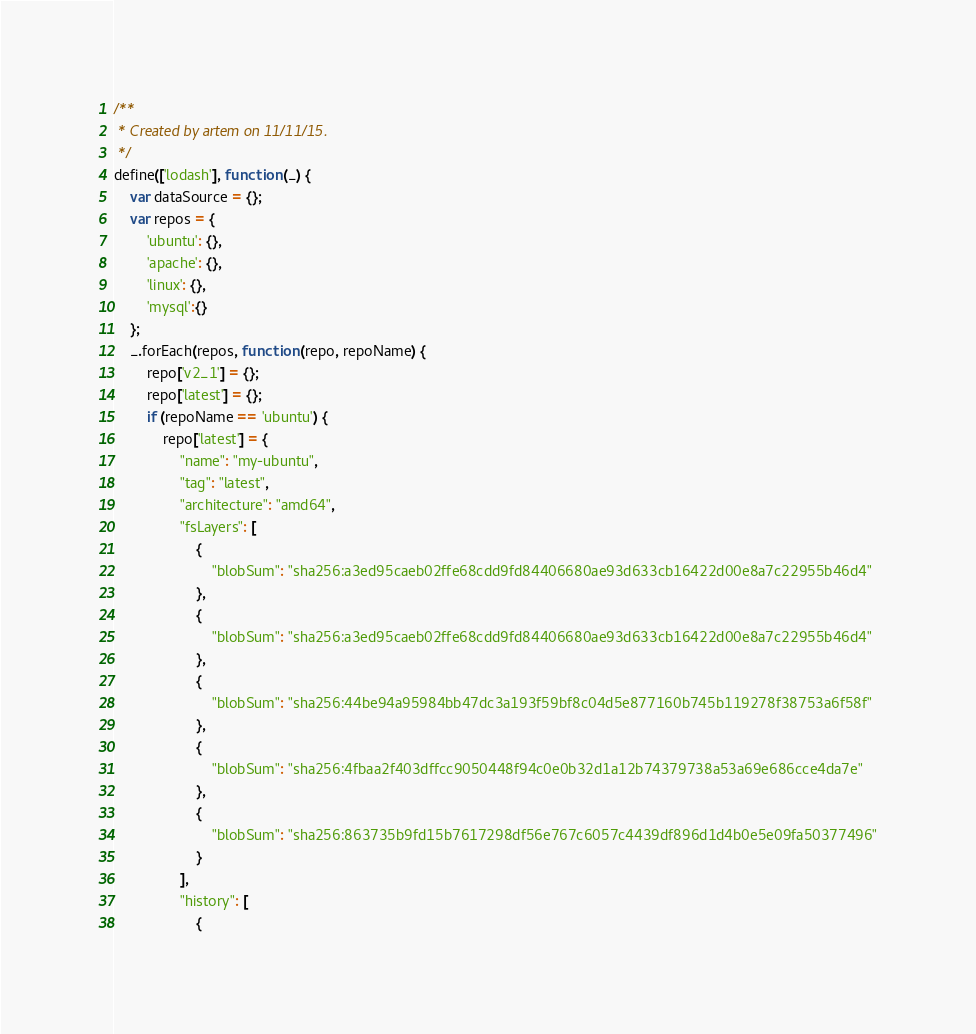Convert code to text. <code><loc_0><loc_0><loc_500><loc_500><_JavaScript_>/**
 * Created by artem on 11/11/15.
 */
define(['lodash'], function (_) {
    var dataSource = {};
    var repos = {
        'ubuntu': {},
        'apache': {},
        'linux': {},
        'mysql':{}
    };
    _.forEach(repos, function (repo, repoName) {
        repo['v2_1'] = {};
        repo['latest'] = {};
        if (repoName == 'ubuntu') {
            repo['latest'] = {
                "name": "my-ubuntu",
                "tag": "latest",
                "architecture": "amd64",
                "fsLayers": [
                    {
                        "blobSum": "sha256:a3ed95caeb02ffe68cdd9fd84406680ae93d633cb16422d00e8a7c22955b46d4"
                    },
                    {
                        "blobSum": "sha256:a3ed95caeb02ffe68cdd9fd84406680ae93d633cb16422d00e8a7c22955b46d4"
                    },
                    {
                        "blobSum": "sha256:44be94a95984bb47dc3a193f59bf8c04d5e877160b745b119278f38753a6f58f"
                    },
                    {
                        "blobSum": "sha256:4fbaa2f403dffcc9050448f94c0e0b32d1a12b74379738a53a69e686cce4da7e"
                    },
                    {
                        "blobSum": "sha256:863735b9fd15b7617298df56e767c6057c4439df896d1d4b0e5e09fa50377496"
                    }
                ],
                "history": [
                    {</code> 